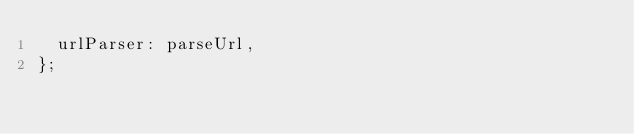<code> <loc_0><loc_0><loc_500><loc_500><_TypeScript_>  urlParser: parseUrl,
};
</code> 